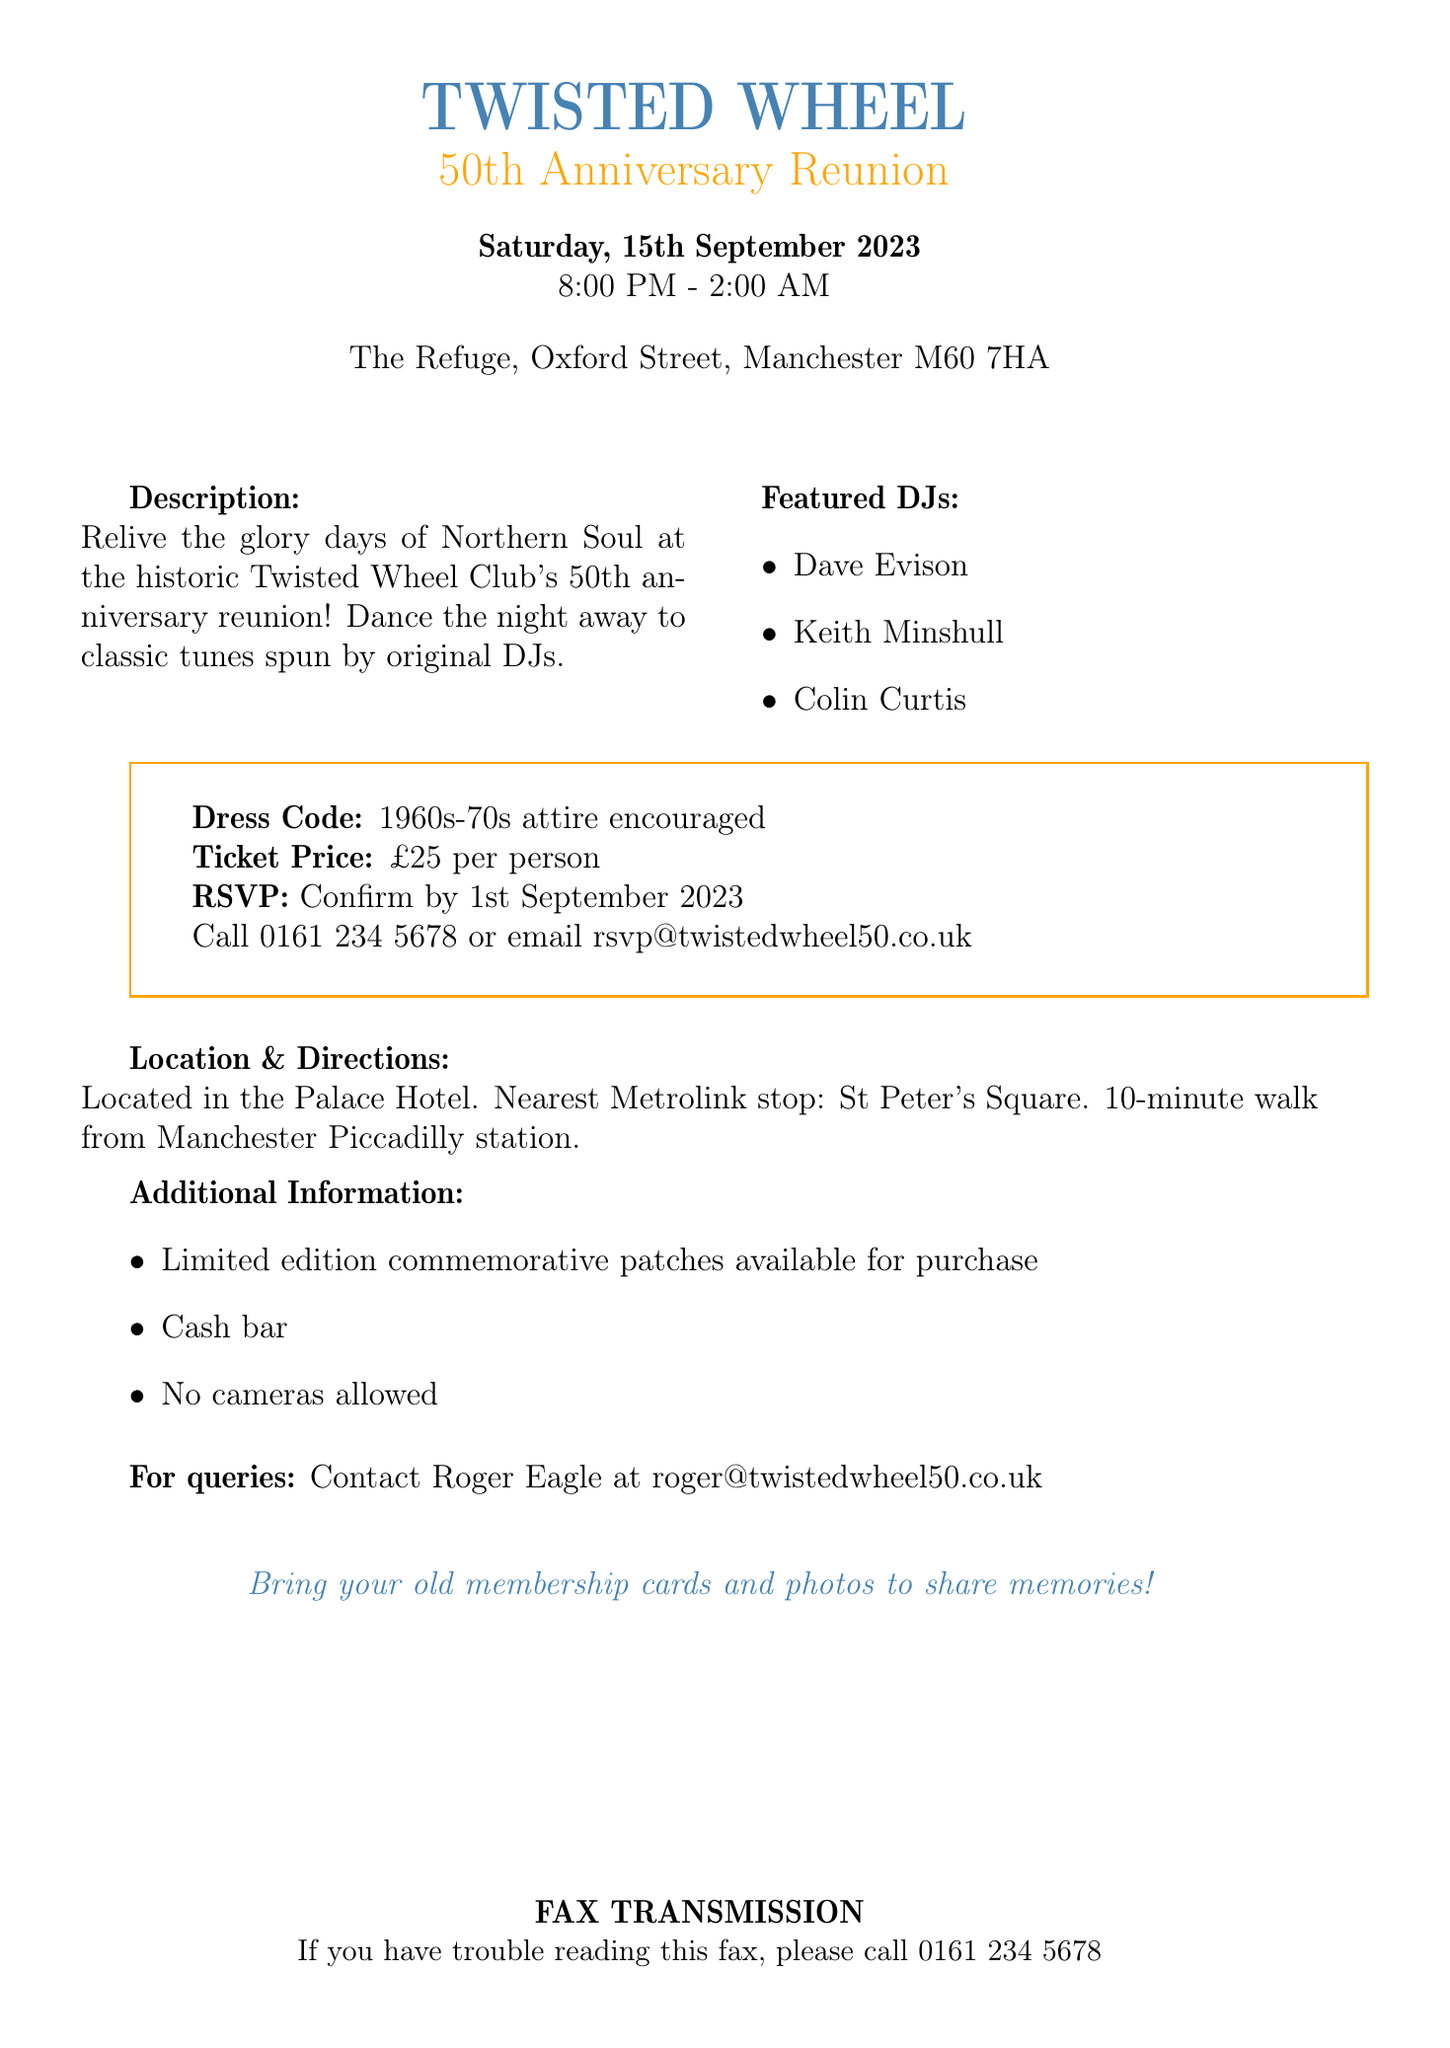What is the title of the event? The title of the event is explicitly stated in the document as the 50th Anniversary Reunion of the Twisted Wheel.
Answer: 50th Anniversary Reunion What is the date of the reunion? The date of the reunion is provided in the document, specifically stated as Saturday, 15th September 2023.
Answer: 15th September 2023 What time does the event start? The start time of the event is explicitly mentioned in the document as 8:00 PM.
Answer: 8:00 PM Who are the featured DJs? The document lists the featured DJs as Dave Evison, Keith Minshull, and Colin Curtis.
Answer: Dave Evison, Keith Minshull, Colin Curtis What is the ticket price? The ticket price is clearly stated in the document as £25 per person.
Answer: £25 per person What is the RSVP deadline? The deadline for RSVPs is stated as 1st September 2023 in the document.
Answer: 1st September 2023 What is encouraged as the dress code? The document encourages attendees to wear 1960s-70s attire.
Answer: 1960s-70s attire Where is the reunion being held? The location of the reunion is specified in the document as The Refuge, Oxford Street, Manchester M60 7HA.
Answer: The Refuge, Oxford Street, Manchester M60 7HA What is specifically not allowed at the event? The document clearly states that no cameras are allowed at the event.
Answer: No cameras allowed 